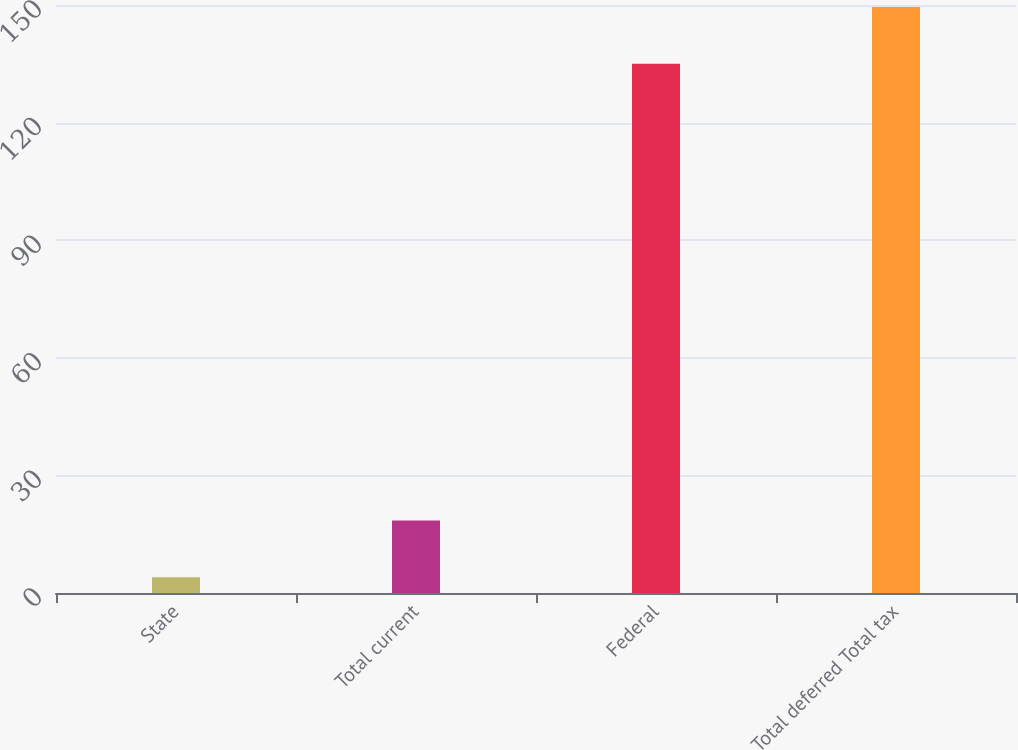Convert chart. <chart><loc_0><loc_0><loc_500><loc_500><bar_chart><fcel>State<fcel>Total current<fcel>Federal<fcel>Total deferred Total tax<nl><fcel>4<fcel>18.5<fcel>135<fcel>149.5<nl></chart> 